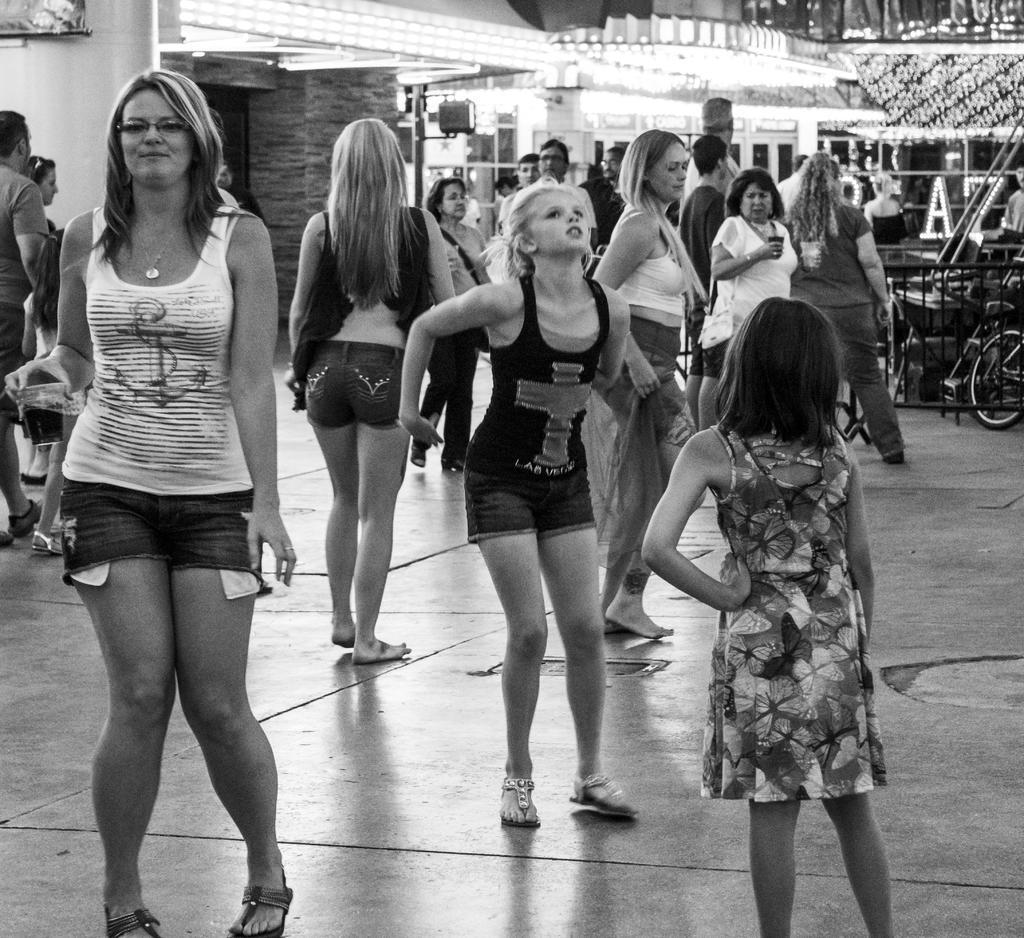How many people are in the image? There is a group of people in the image. What are the people doing in the image? The people are standing on the floor. What other object can be seen in the image besides the people? There is a bicycle in the image. What can be seen in the background of the image? There are lights and pillars in the background of the image. What type of meat is being served at the family gathering in the image? There is no family gathering or meat present in the image. What color is the scarf worn by the person in the image? There is no scarf visible in the image. 